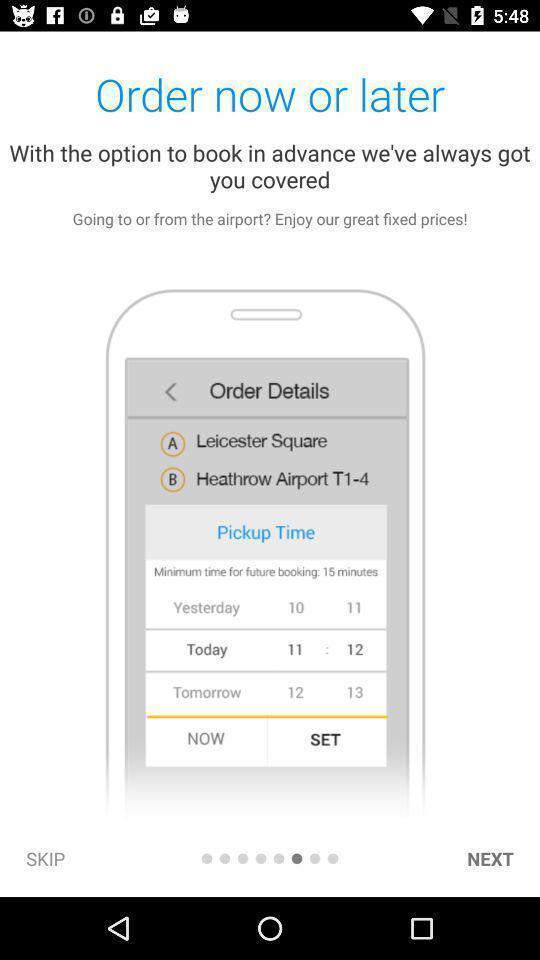Explain what's happening in this screen capture. Welcome page for a advance ride booking app. 